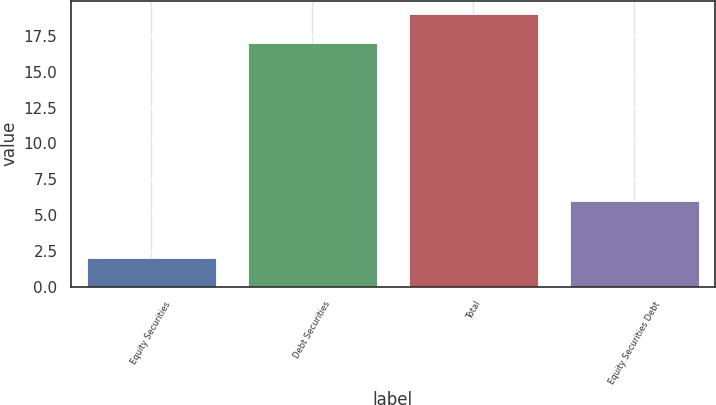Convert chart. <chart><loc_0><loc_0><loc_500><loc_500><bar_chart><fcel>Equity Securities<fcel>Debt Securities<fcel>Total<fcel>Equity Securities Debt<nl><fcel>2<fcel>17<fcel>19<fcel>6<nl></chart> 